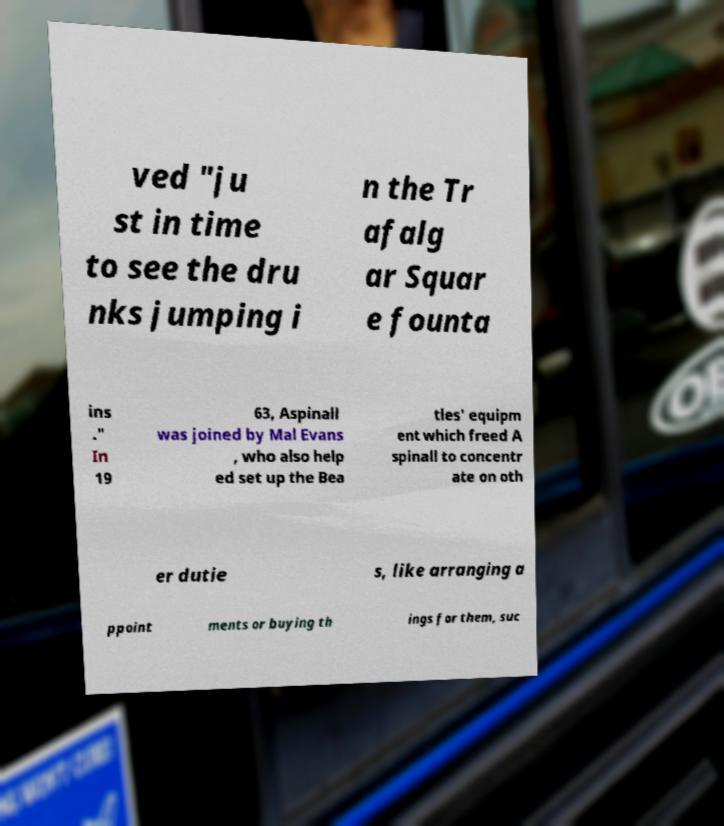I need the written content from this picture converted into text. Can you do that? ved "ju st in time to see the dru nks jumping i n the Tr afalg ar Squar e founta ins ." In 19 63, Aspinall was joined by Mal Evans , who also help ed set up the Bea tles' equipm ent which freed A spinall to concentr ate on oth er dutie s, like arranging a ppoint ments or buying th ings for them, suc 